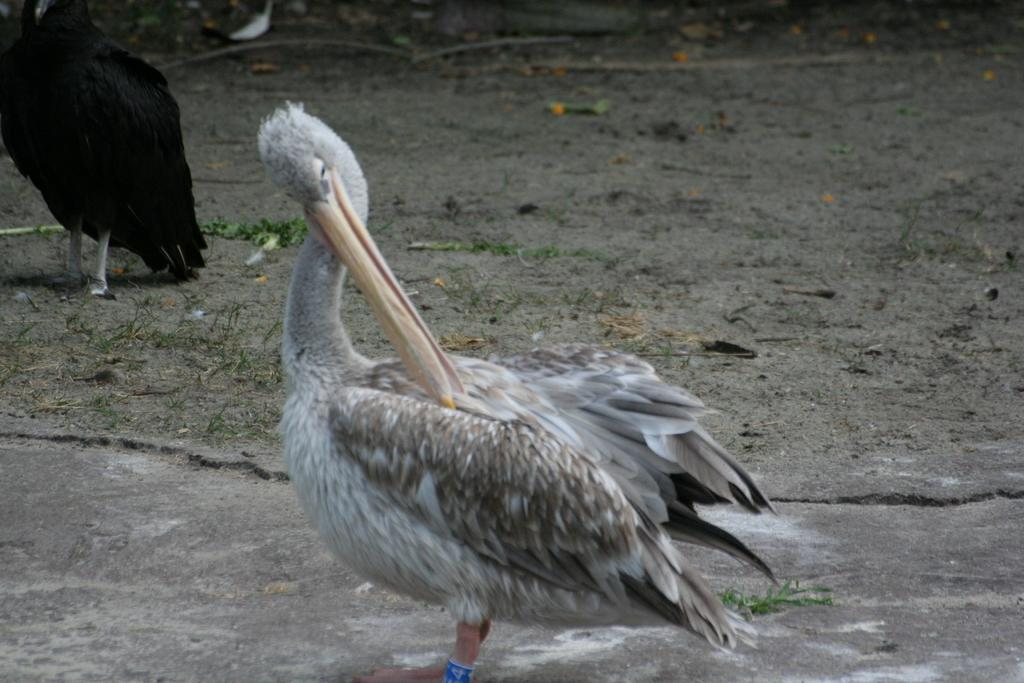What type of animals can be seen on the ground in the image? There are birds on the ground in the image. What else can be found on the ground in the image? There are leaves on the ground in the image. What type of trade is happening between the birds in the image? There is no indication of any trade happening between the birds in the image. Can you describe the division of the leaves on the ground in the image? The leaves on the ground are not divided in any specific way; they are simply scattered. 